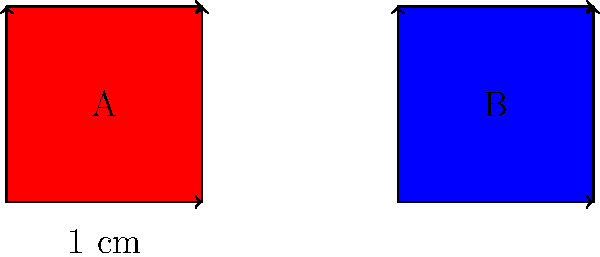In traditional Chinese paper-cutting art, two square patterns A and B are shown above. Each side of both squares measures 1 cm. Are these two paper-cut patterns congruent? To determine if the two paper-cut patterns are congruent, we need to check if they have the same shape and size. Let's analyze the given information step by step:

1. Shape: Both patterns A and B are squares.

2. Size: 
   - Pattern A: All sides measure 1 cm
   - Pattern B: All sides measure 1 cm

3. Definition of congruence: Two geometric figures are congruent if they have the same shape and size, meaning that one figure can be superimposed on the other without any gaps or overlaps.

4. Comparing A and B:
   - They have the same shape (square)
   - They have the same size (1 cm × 1 cm)

5. Transformation: We can translate (move) pattern A to the position of pattern B without any rotation or reflection, and they will perfectly overlap.

Therefore, since patterns A and B have the same shape and size, and one can be superimposed on the other without any changes, they are congruent.
Answer: Yes 